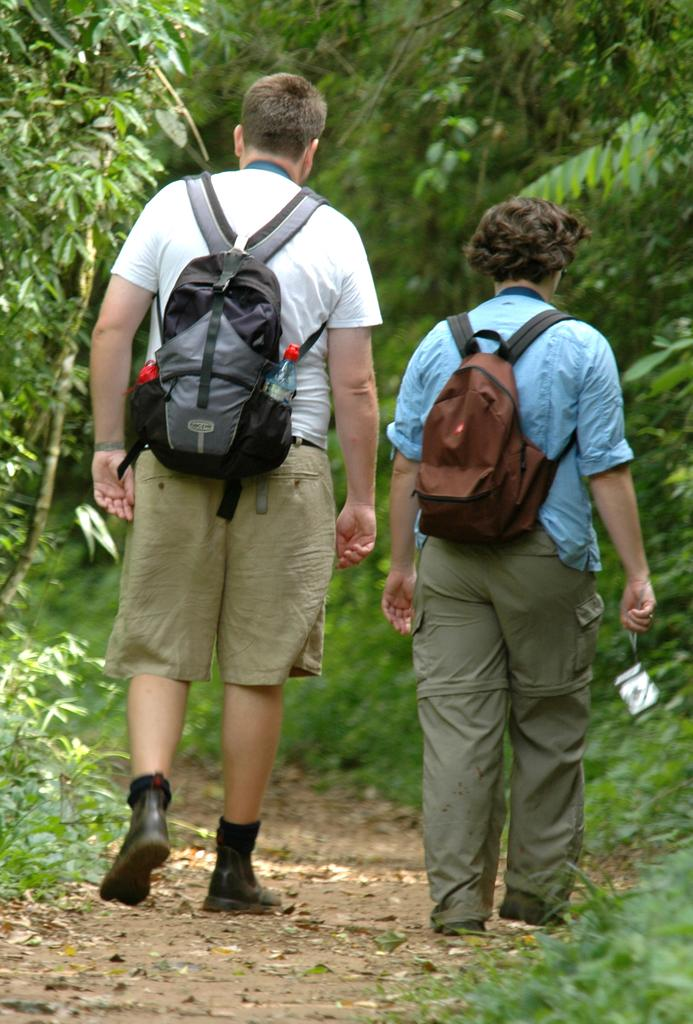How many people are in the image? There are two persons in the image. What are the persons doing in the image? The persons are walking. What are the persons carrying while walking? The persons are carrying bags. Can you describe the contents of one of the bags? There is a bottle in one of the bags. What can be seen in the background of the image? Trees are visible in front of the persons. What time of day is it in the image, considering the presence of fog? There is no mention of fog in the image, so it cannot be determined if the time of day is affected by fog. 